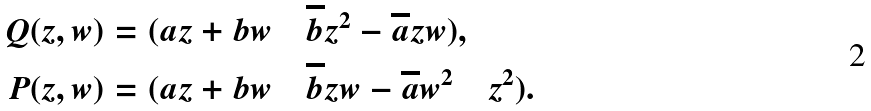<formula> <loc_0><loc_0><loc_500><loc_500>Q ( z , w ) & = ( a z + b w \quad \overline { b } z ^ { 2 } - \overline { a } z w ) , \\ P ( z , w ) & = ( a z + b w \quad \overline { b } z w - \overline { a } w ^ { 2 } \quad z ^ { 2 } ) .</formula> 